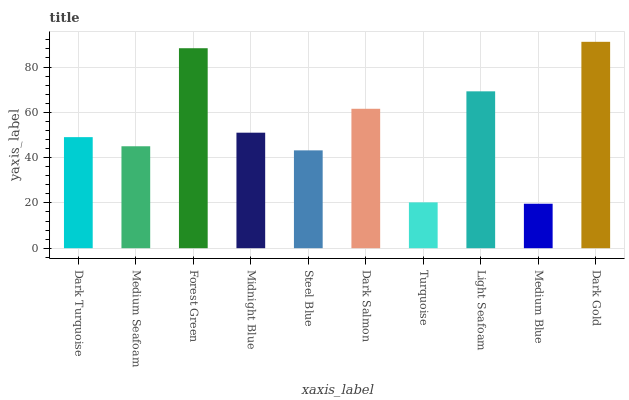Is Medium Seafoam the minimum?
Answer yes or no. No. Is Medium Seafoam the maximum?
Answer yes or no. No. Is Dark Turquoise greater than Medium Seafoam?
Answer yes or no. Yes. Is Medium Seafoam less than Dark Turquoise?
Answer yes or no. Yes. Is Medium Seafoam greater than Dark Turquoise?
Answer yes or no. No. Is Dark Turquoise less than Medium Seafoam?
Answer yes or no. No. Is Midnight Blue the high median?
Answer yes or no. Yes. Is Dark Turquoise the low median?
Answer yes or no. Yes. Is Medium Seafoam the high median?
Answer yes or no. No. Is Dark Salmon the low median?
Answer yes or no. No. 